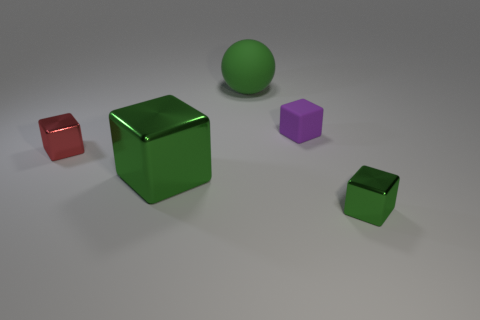Subtract all gray cubes. Subtract all green cylinders. How many cubes are left? 4 Add 5 large yellow metal cylinders. How many objects exist? 10 Subtract all blocks. How many objects are left? 1 Subtract all tiny purple things. Subtract all small red metallic blocks. How many objects are left? 3 Add 3 large green matte objects. How many large green matte objects are left? 4 Add 1 tiny brown metal cylinders. How many tiny brown metal cylinders exist? 1 Subtract 0 yellow cylinders. How many objects are left? 5 